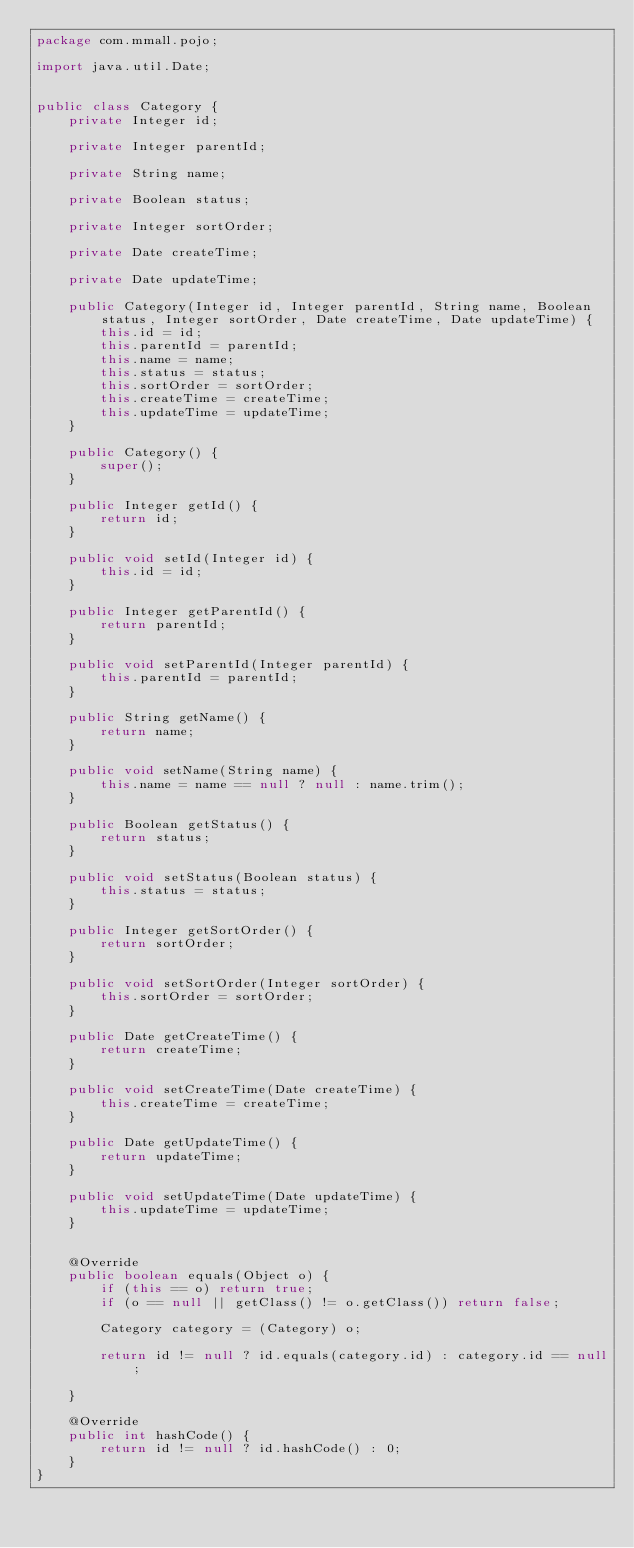<code> <loc_0><loc_0><loc_500><loc_500><_Java_>package com.mmall.pojo;

import java.util.Date;


public class Category {
    private Integer id;

    private Integer parentId;

    private String name;

    private Boolean status;

    private Integer sortOrder;

    private Date createTime;

    private Date updateTime;

    public Category(Integer id, Integer parentId, String name, Boolean status, Integer sortOrder, Date createTime, Date updateTime) {
        this.id = id;
        this.parentId = parentId;
        this.name = name;
        this.status = status;
        this.sortOrder = sortOrder;
        this.createTime = createTime;
        this.updateTime = updateTime;
    }

    public Category() {
        super();
    }

    public Integer getId() {
        return id;
    }

    public void setId(Integer id) {
        this.id = id;
    }

    public Integer getParentId() {
        return parentId;
    }

    public void setParentId(Integer parentId) {
        this.parentId = parentId;
    }

    public String getName() {
        return name;
    }

    public void setName(String name) {
        this.name = name == null ? null : name.trim();
    }

    public Boolean getStatus() {
        return status;
    }

    public void setStatus(Boolean status) {
        this.status = status;
    }

    public Integer getSortOrder() {
        return sortOrder;
    }

    public void setSortOrder(Integer sortOrder) {
        this.sortOrder = sortOrder;
    }

    public Date getCreateTime() {
        return createTime;
    }

    public void setCreateTime(Date createTime) {
        this.createTime = createTime;
    }

    public Date getUpdateTime() {
        return updateTime;
    }

    public void setUpdateTime(Date updateTime) {
        this.updateTime = updateTime;
    }


    @Override
    public boolean equals(Object o) {
        if (this == o) return true;
        if (o == null || getClass() != o.getClass()) return false;

        Category category = (Category) o;

        return id != null ? id.equals(category.id) : category.id == null;

    }

    @Override
    public int hashCode() {
        return id != null ? id.hashCode() : 0;
    }
}</code> 